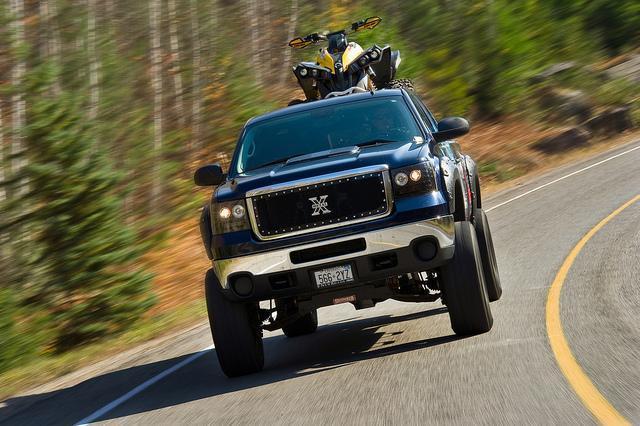How many pizzas are on the table?
Give a very brief answer. 0. 